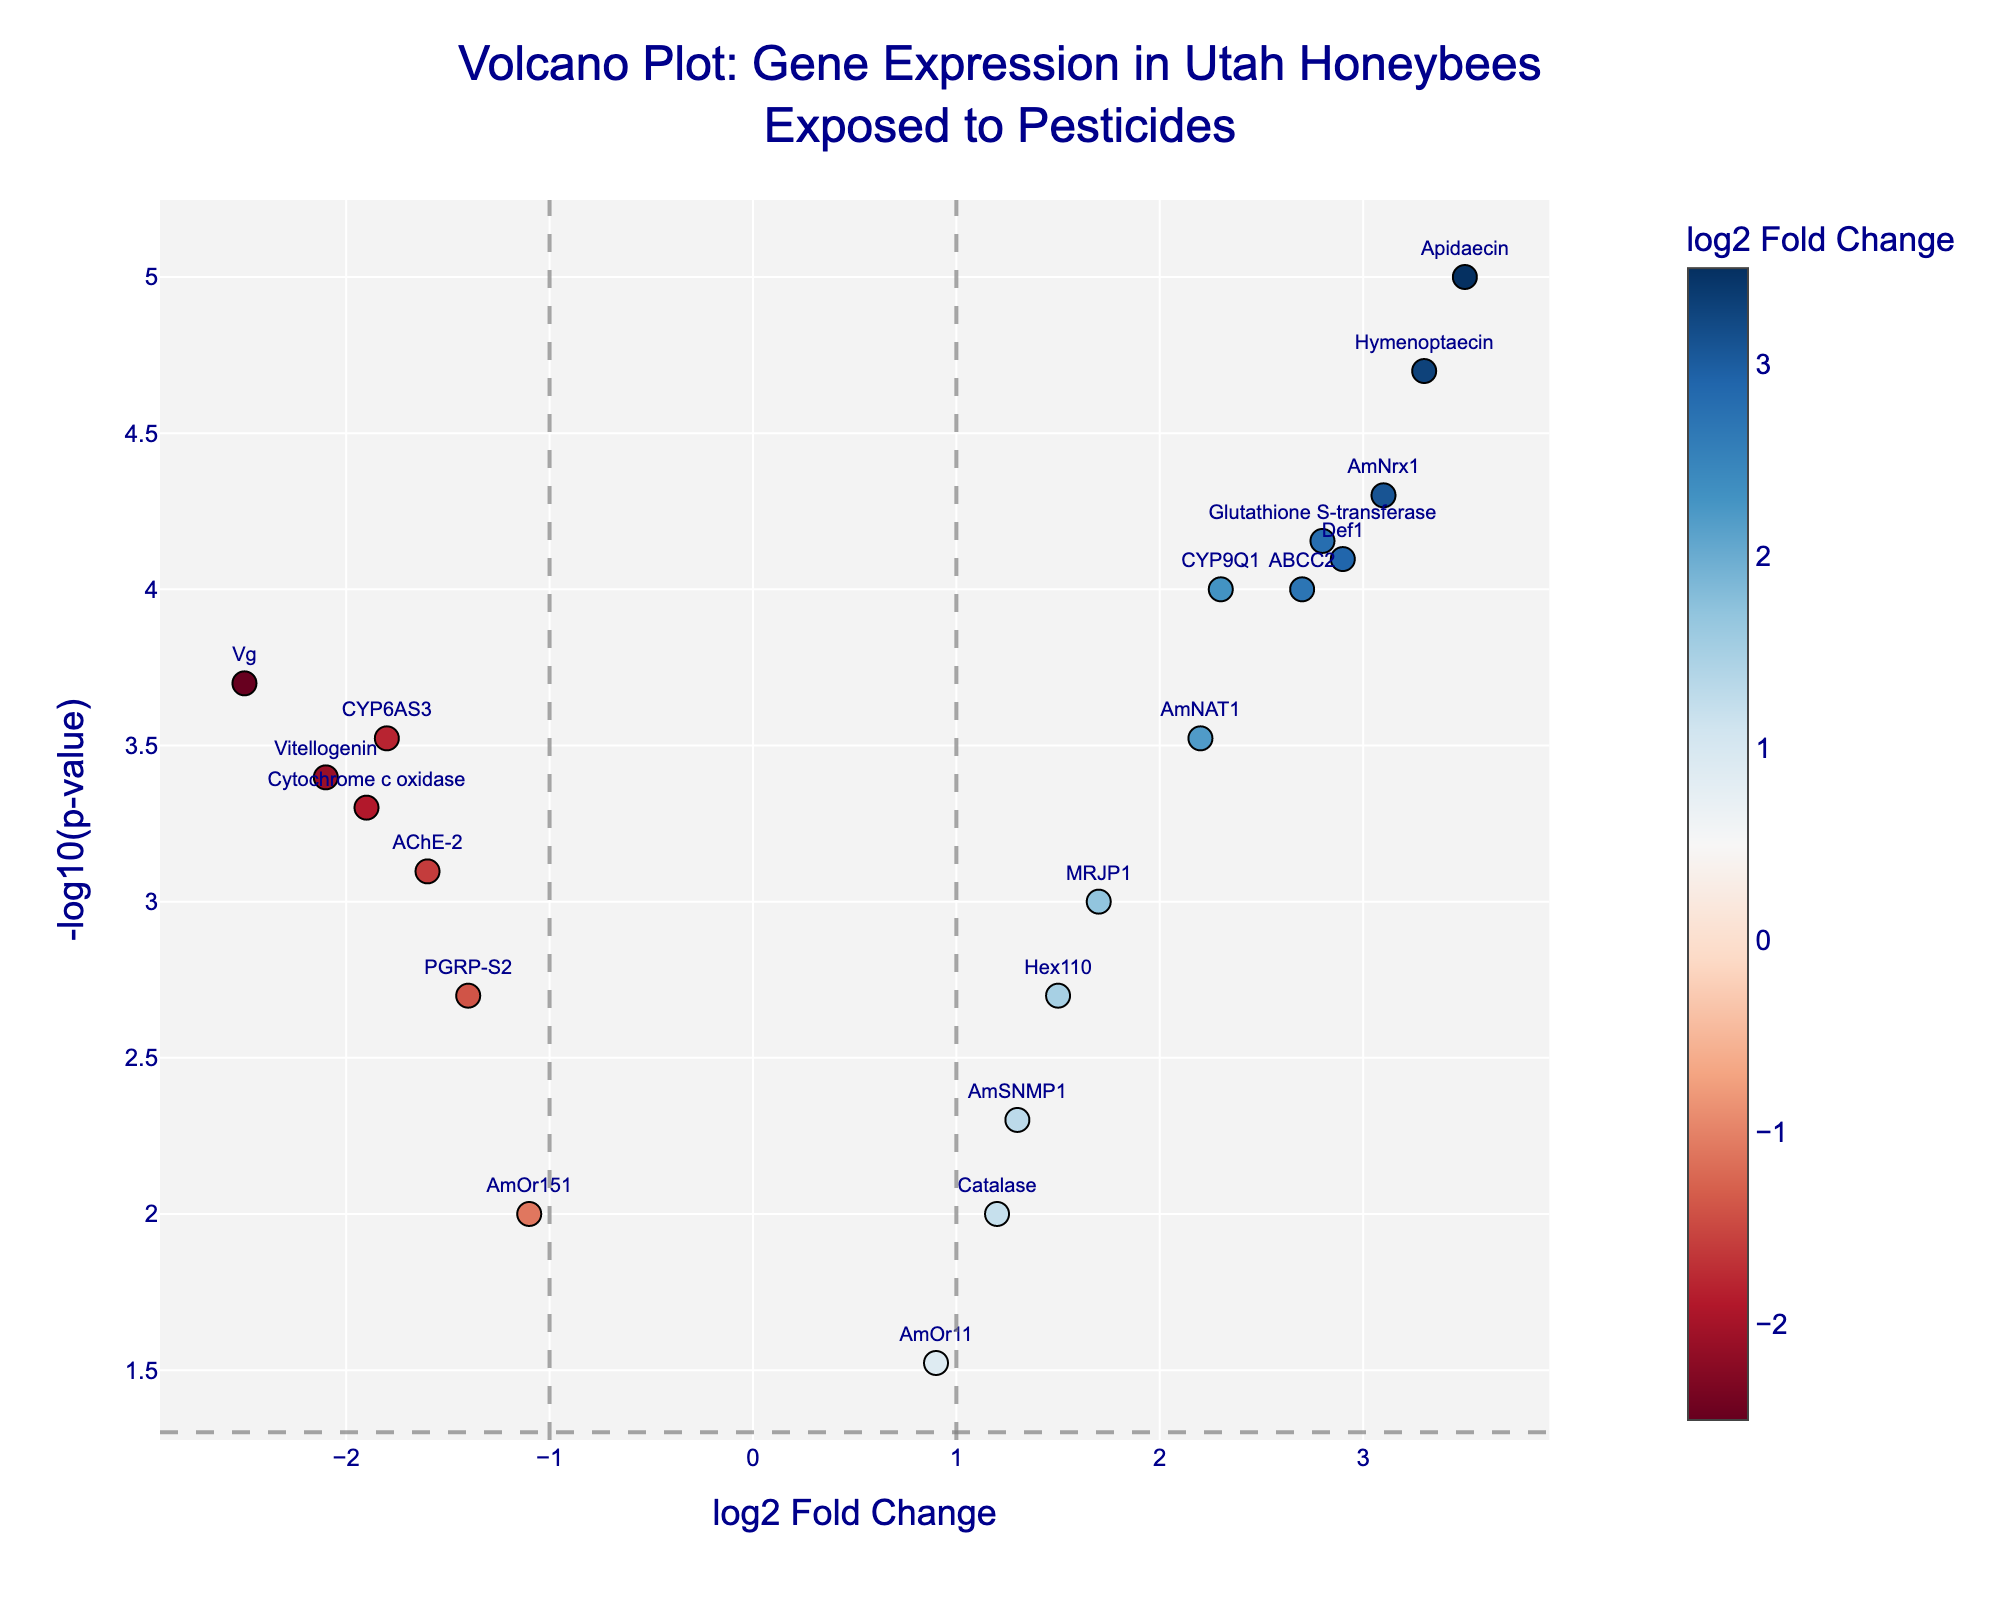What is the title of the plot? The title is displayed prominently at the top of the plot, which reads "Volcano Plot: Gene Expression in Utah Honeybees Exposed to Pesticides".
Answer: Volcano Plot: Gene Expression in Utah Honeybees Exposed to Pesticides What are the x and y-axis labels? The x-axis is labeled "log2 Fold Change", and the y-axis is labeled "-log10(p-value)".
Answer: log2 Fold Change, -log10(p-value) How many genes have a log2 fold change greater than 2? By observing the x-axis values to the right of 2, the genes with log2 fold changes greater than 2 can be counted. The genes are CYP9Q1, AmNrx1, Def1, Apidaecin, ABCC2, Glutathione S-transferase, and Hymenoptaecin, totaling 7.
Answer: 7 What is the significance threshold marked on the y-axis? The horizontal line on the y-axis corresponds to the -log10 of the p-value cutoff of 0.05, which is -log10(0.05) ≈ 1.3.
Answer: 1.3 Which gene has the highest log2 fold change and what is its p-value? By locating the highest point on the x-axis, Apidaecin has the highest log2 fold change, with a log2FC of 3.5 and a p-value of 0.00001.
Answer: Apidaecin, 0.00001 Which genes are likely to be most significant in terms of changes due to pesticide exposure? The most significant genes have both high absolute values of log2 fold change and low p-values, typically identifiable by their position far from the origin on both axes. Notable genes include Apidaecin, Def1, Hymenoptaecin, and Glutathione S-transferase.
Answer: Apidaecin, Def1, Hymenoptaecin, Glutathione S-transferase Which gene has the lowest log2 fold change and is it upregulated or downregulated? The gene with the lowest log2 fold change is Vg with a log2FC of -2.5, indicating it is downregulated.
Answer: Vg, downregulated Compare the p-values of genes Vg and CYP9Q1, which one is less significant? The p-values of Vg (0.0002) and CYP9Q1 (0.0001) are compared. Since -log10(p-value) is higher for CYP9Q1, it is more significant, thus Vg (0.0002) is less significant.
Answer: Vg What is the color of the marker for gene AmNrx1 and what does it indicate? The color of the marker for AmNrx1 would be on the extremes of the color scale, indicating high positive fold change, specifically dark red. This color scale represents the log2 fold change.
Answer: Dark red indicating high positive fold change How many genes have a p-value less than 0.001 and what does it imply about their significance? Counting the genes whose y-values are greater than -log10(0.001) ≈ 3, there are Apidaecin, Hymenoptaecin, AmNrx1, Def1, Glutathione S-transferase, CYP9Q1, and ABCC2, totaling 7. This implies these genes are significantly differentially expressed.
Answer: 7, significantly differentially expressed 